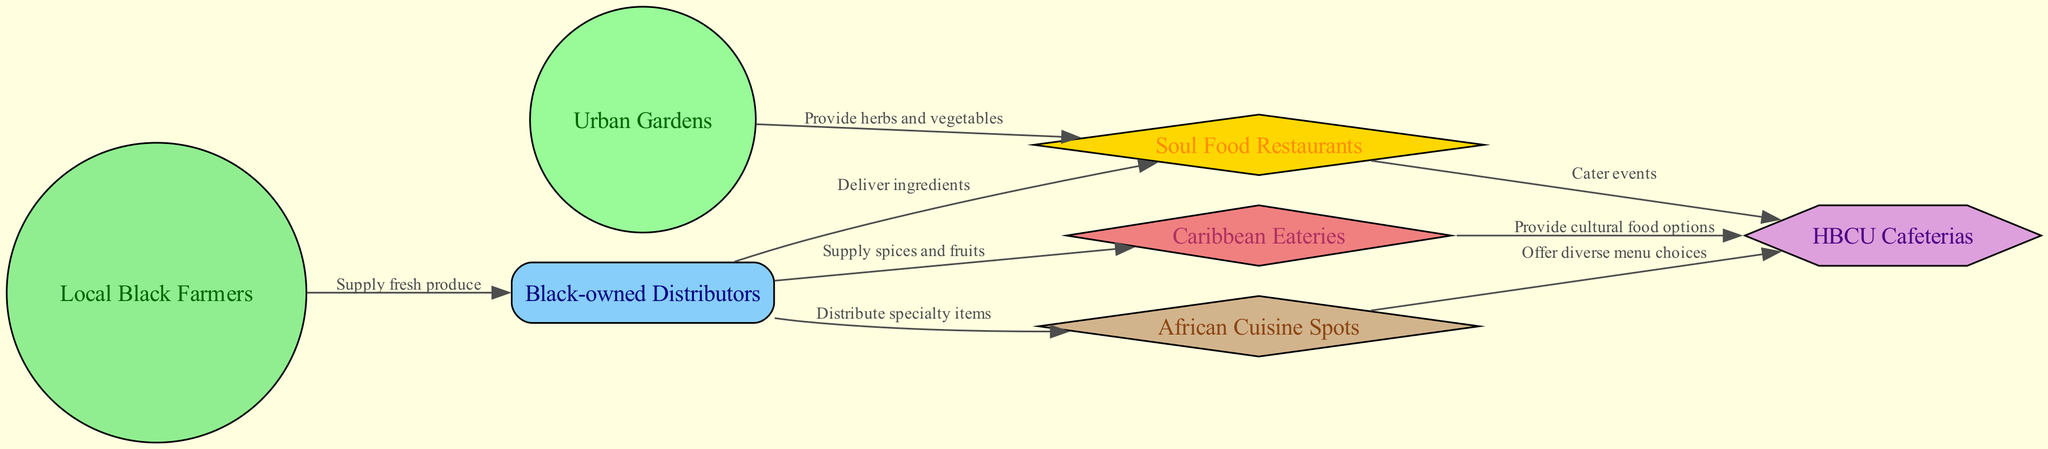What are the nodes in this food chain diagram? The diagram includes various nodes: Local Black Farmers, Urban Gardens, Black-owned Distributors, Soul Food Restaurants, Caribbean Eateries, African Cuisine Spots, and HBCU Cafeterias. These represent different entities involved in the food supply chain in urban communities.
Answer: Local Black Farmers, Urban Gardens, Black-owned Distributors, Soul Food Restaurants, Caribbean Eateries, African Cuisine Spots, HBCU Cafeterias How many edges are in the diagram? By counting the connections (edges) that link the nodes in the diagram, we see there are eight edges connecting various entities, representing the supply relationships.
Answer: 8 Which node supplies fresh produce? The node "Local Black Farmers" is directly connected to "Black-owned Distributors" with an edge labeled "Supply fresh produce," indicating that they are the source of fresh produce in this supply chain.
Answer: Local Black Farmers What type of relationship exists between Urban Gardens and Soul Food Restaurants? Urban Gardens provide herbs and vegetables to Soul Food Restaurants, as indicated by the edge connecting these two nodes, labeled "Provide herbs and vegetables." This denotes a supply relationship.
Answer: Provide herbs and vegetables How do Caribbean Eateries contribute to HBCU Cafeterias? Caribbean Eateries provide cultural food options to HBCU Cafeterias according to the connection shown in the diagram, which represents their contribution to the cafeteria menu.
Answer: Provide cultural food options What is the role of Black-owned Distributors in the supply chain? Black-owned Distributors play a crucial role by delivering ingredients to Soul Food Restaurants and supplying spices and fruits to Caribbean Eateries and distributing specialty items to African Cuisine Spots. This illustrates their function as a central hub in the food supply chain.
Answer: Deliver ingredients, Supply spices and fruits, Distribute specialty items Which node caters events in the diagram? The edge from Soul Food Restaurants to HBCU Cafeterias is labeled "Cater events," which indicates that Soul Food Restaurants provide catering services for events hosted at HBCU Cafeterias.
Answer: Soul Food Restaurants What is the connection between African Cuisine Spots and HBCU Cafeterias? African Cuisine Spots offer diverse menu choices to HBCU Cafeterias, as evidenced by the edge connecting these nodes with the label "Offer diverse menu choices." This reflects the supply of various food options for the cafeterias.
Answer: Offer diverse menu choices 